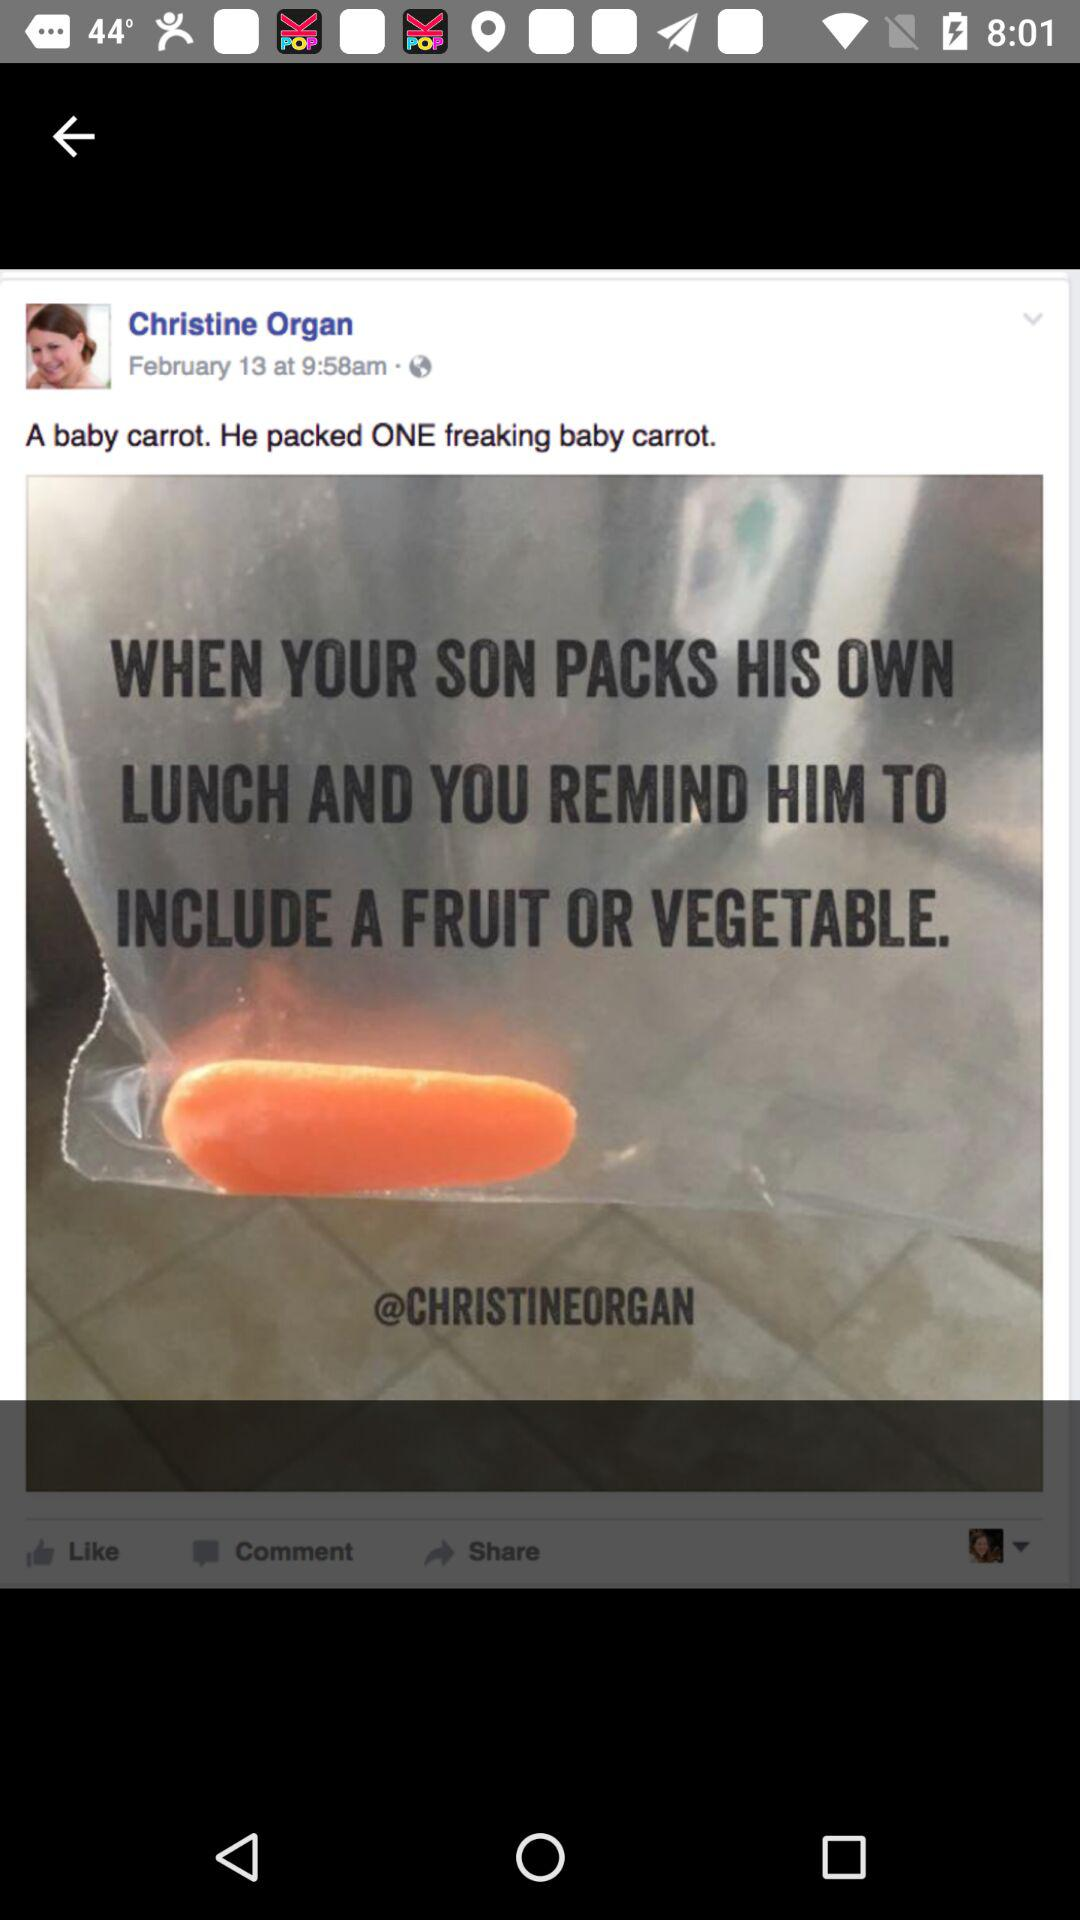How many baby carrots are packed? There is one baby carrot packed. 